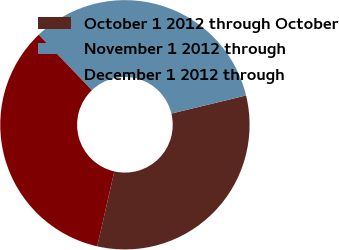Convert chart. <chart><loc_0><loc_0><loc_500><loc_500><pie_chart><fcel>October 1 2012 through October<fcel>November 1 2012 through<fcel>December 1 2012 through<nl><fcel>32.34%<fcel>33.37%<fcel>34.29%<nl></chart> 